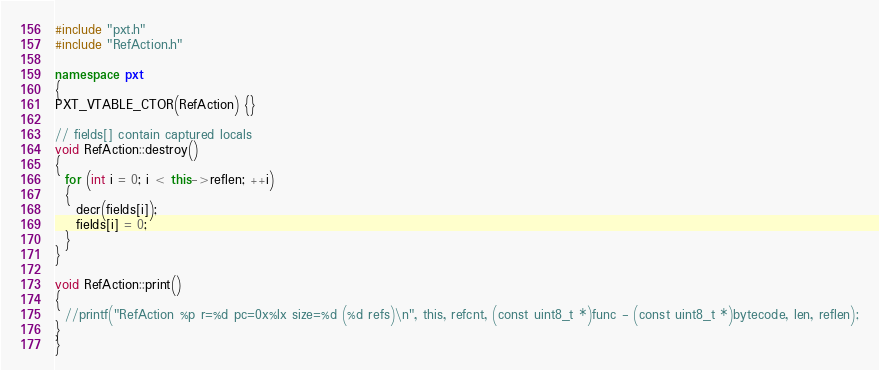<code> <loc_0><loc_0><loc_500><loc_500><_C++_>#include "pxt.h"
#include "RefAction.h"

namespace pxt
{
PXT_VTABLE_CTOR(RefAction) {}

// fields[] contain captured locals
void RefAction::destroy()
{
  for (int i = 0; i < this->reflen; ++i)
  {
    decr(fields[i]);
    fields[i] = 0;
  }
}

void RefAction::print()
{
  //printf("RefAction %p r=%d pc=0x%lx size=%d (%d refs)\n", this, refcnt, (const uint8_t *)func - (const uint8_t *)bytecode, len, reflen);
}
}</code> 